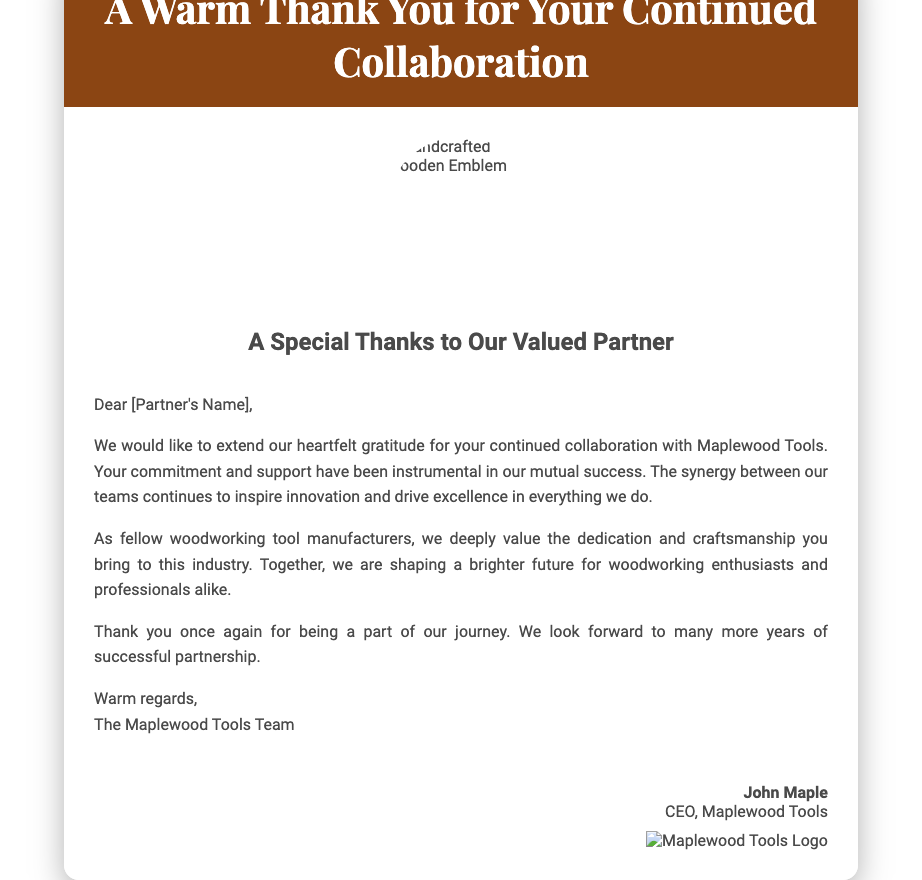What is the title of the card? The title of the card is prominently displayed in the header section of the document.
Answer: A Warm Thank You for Your Continued Collaboration Who is the card addressed to? The card is addressed to the partner, though the specific name is a placeholder.
Answer: [Partner's Name] What is the name of the company mentioned in the card? The company's name is stated in the message section of the card.
Answer: Maplewood Tools Who signed the card? The signature block at the end of the card reveals the individual who signed it.
Answer: John Maple What is the overall theme of the card? The card's theme is expressed through its message of gratitude and collaboration in the woodworking industry.
Answer: Gratitude for collaboration What kind of background does the card have? The background of the card is described in the CSS portion of the document, which indicates its texture.
Answer: Rustic woodgrain How many images are included in the card? The card contains two images that are referenced in the HTML code.
Answer: Two What role does John Maple hold at Maplewood Tools? The signature section mentions his title and position within the company.
Answer: CEO What feeling does the card convey? The message and tone of the card together suggest a positive sentiment towards the recipient.
Answer: Appreciation 